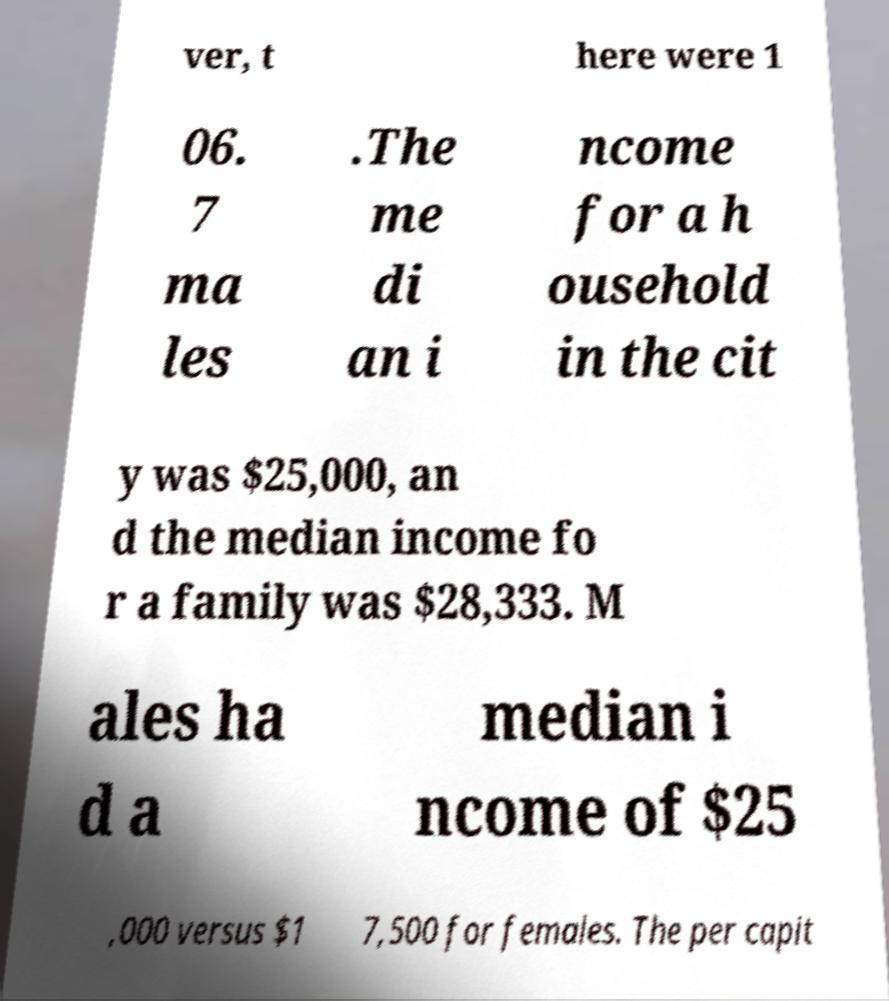Could you assist in decoding the text presented in this image and type it out clearly? ver, t here were 1 06. 7 ma les .The me di an i ncome for a h ousehold in the cit y was $25,000, an d the median income fo r a family was $28,333. M ales ha d a median i ncome of $25 ,000 versus $1 7,500 for females. The per capit 